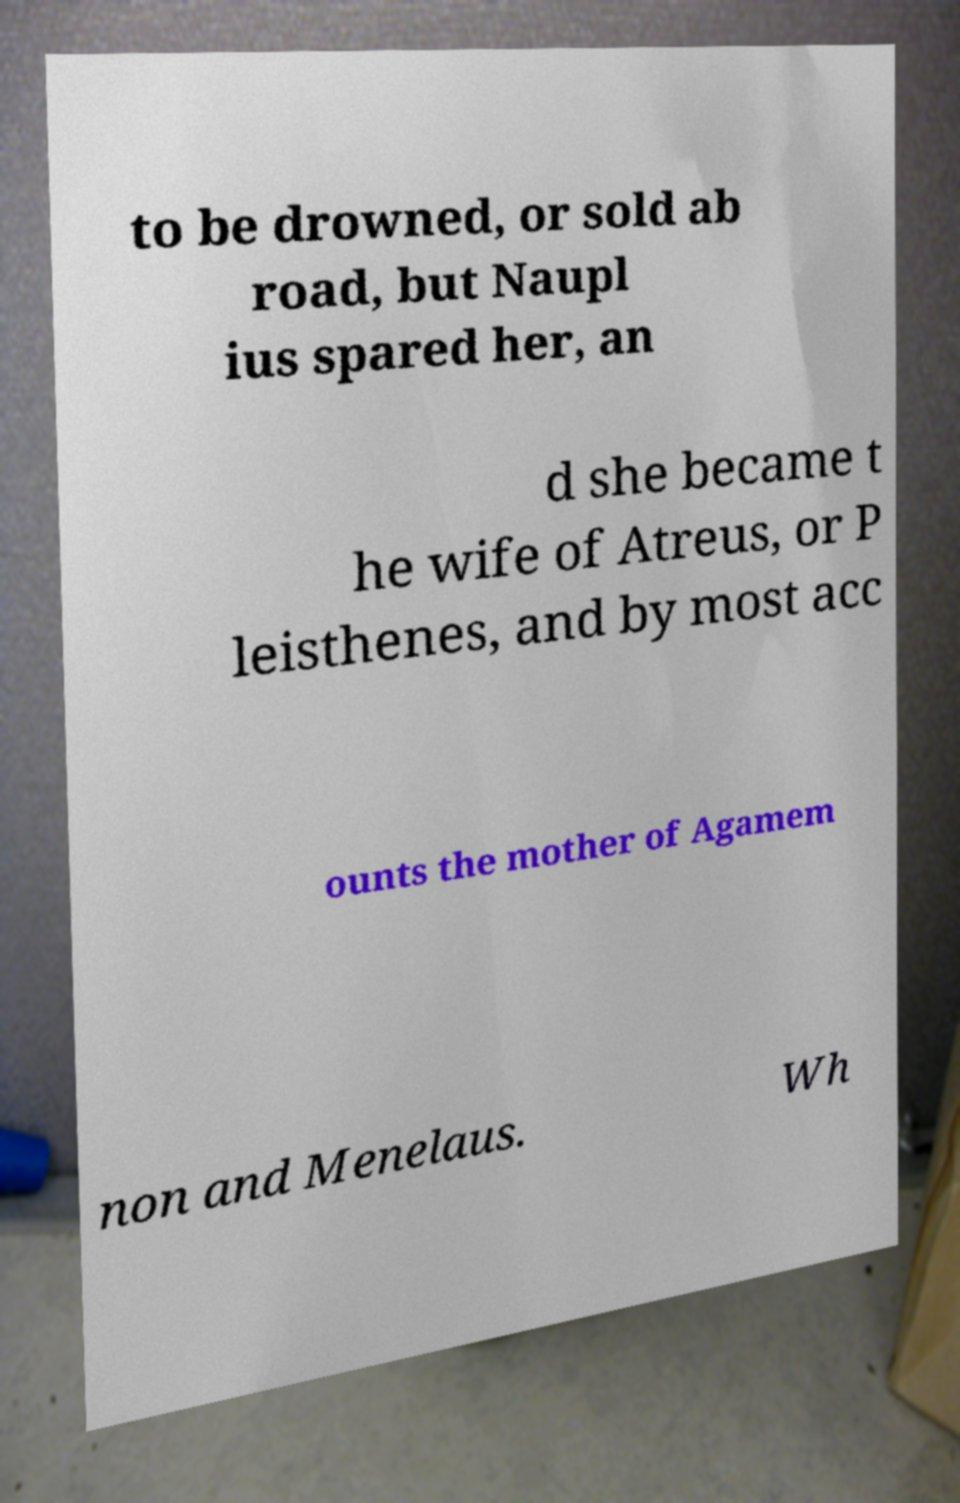I need the written content from this picture converted into text. Can you do that? to be drowned, or sold ab road, but Naupl ius spared her, an d she became t he wife of Atreus, or P leisthenes, and by most acc ounts the mother of Agamem non and Menelaus. Wh 